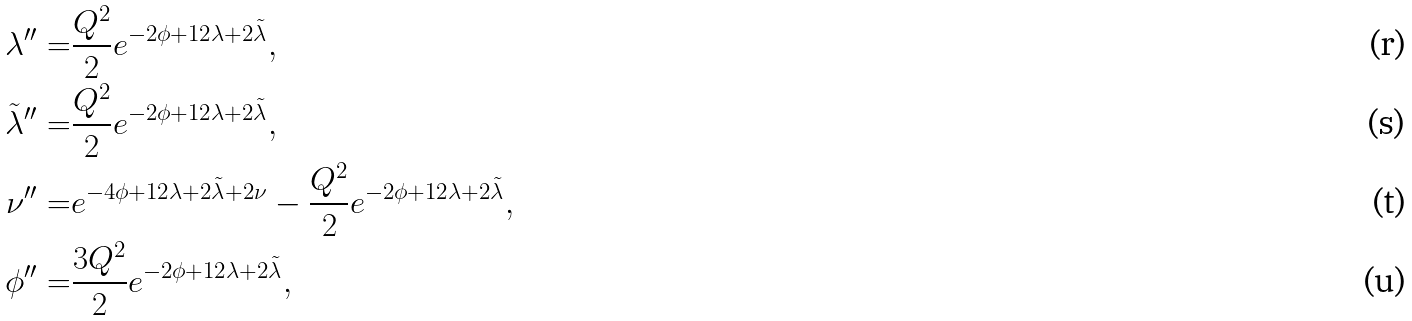Convert formula to latex. <formula><loc_0><loc_0><loc_500><loc_500>\lambda ^ { \prime \prime } = & \frac { Q ^ { 2 } } { 2 } e ^ { - 2 \phi + 1 2 \lambda + 2 \tilde { \lambda } } , \\ \tilde { \lambda } ^ { \prime \prime } = & \frac { Q ^ { 2 } } { 2 } e ^ { - 2 \phi + 1 2 \lambda + 2 \tilde { \lambda } } , \\ \nu ^ { \prime \prime } = & e ^ { - 4 \phi + 1 2 \lambda + 2 \tilde { \lambda } + 2 \nu } - \frac { Q ^ { 2 } } { 2 } e ^ { - 2 \phi + 1 2 \lambda + 2 \tilde { \lambda } } , \\ \phi ^ { \prime \prime } = & \frac { 3 Q ^ { 2 } } { 2 } e ^ { - 2 \phi + 1 2 \lambda + 2 \tilde { \lambda } } ,</formula> 